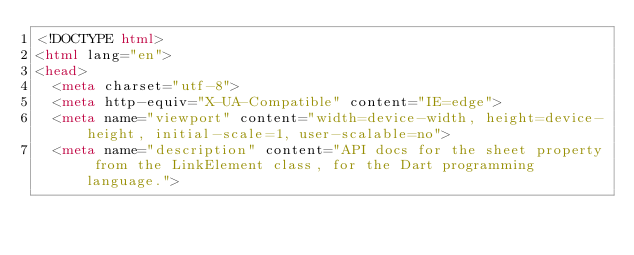<code> <loc_0><loc_0><loc_500><loc_500><_HTML_><!DOCTYPE html>
<html lang="en">
<head>
  <meta charset="utf-8">
  <meta http-equiv="X-UA-Compatible" content="IE=edge">
  <meta name="viewport" content="width=device-width, height=device-height, initial-scale=1, user-scalable=no">
  <meta name="description" content="API docs for the sheet property from the LinkElement class, for the Dart programming language."></code> 